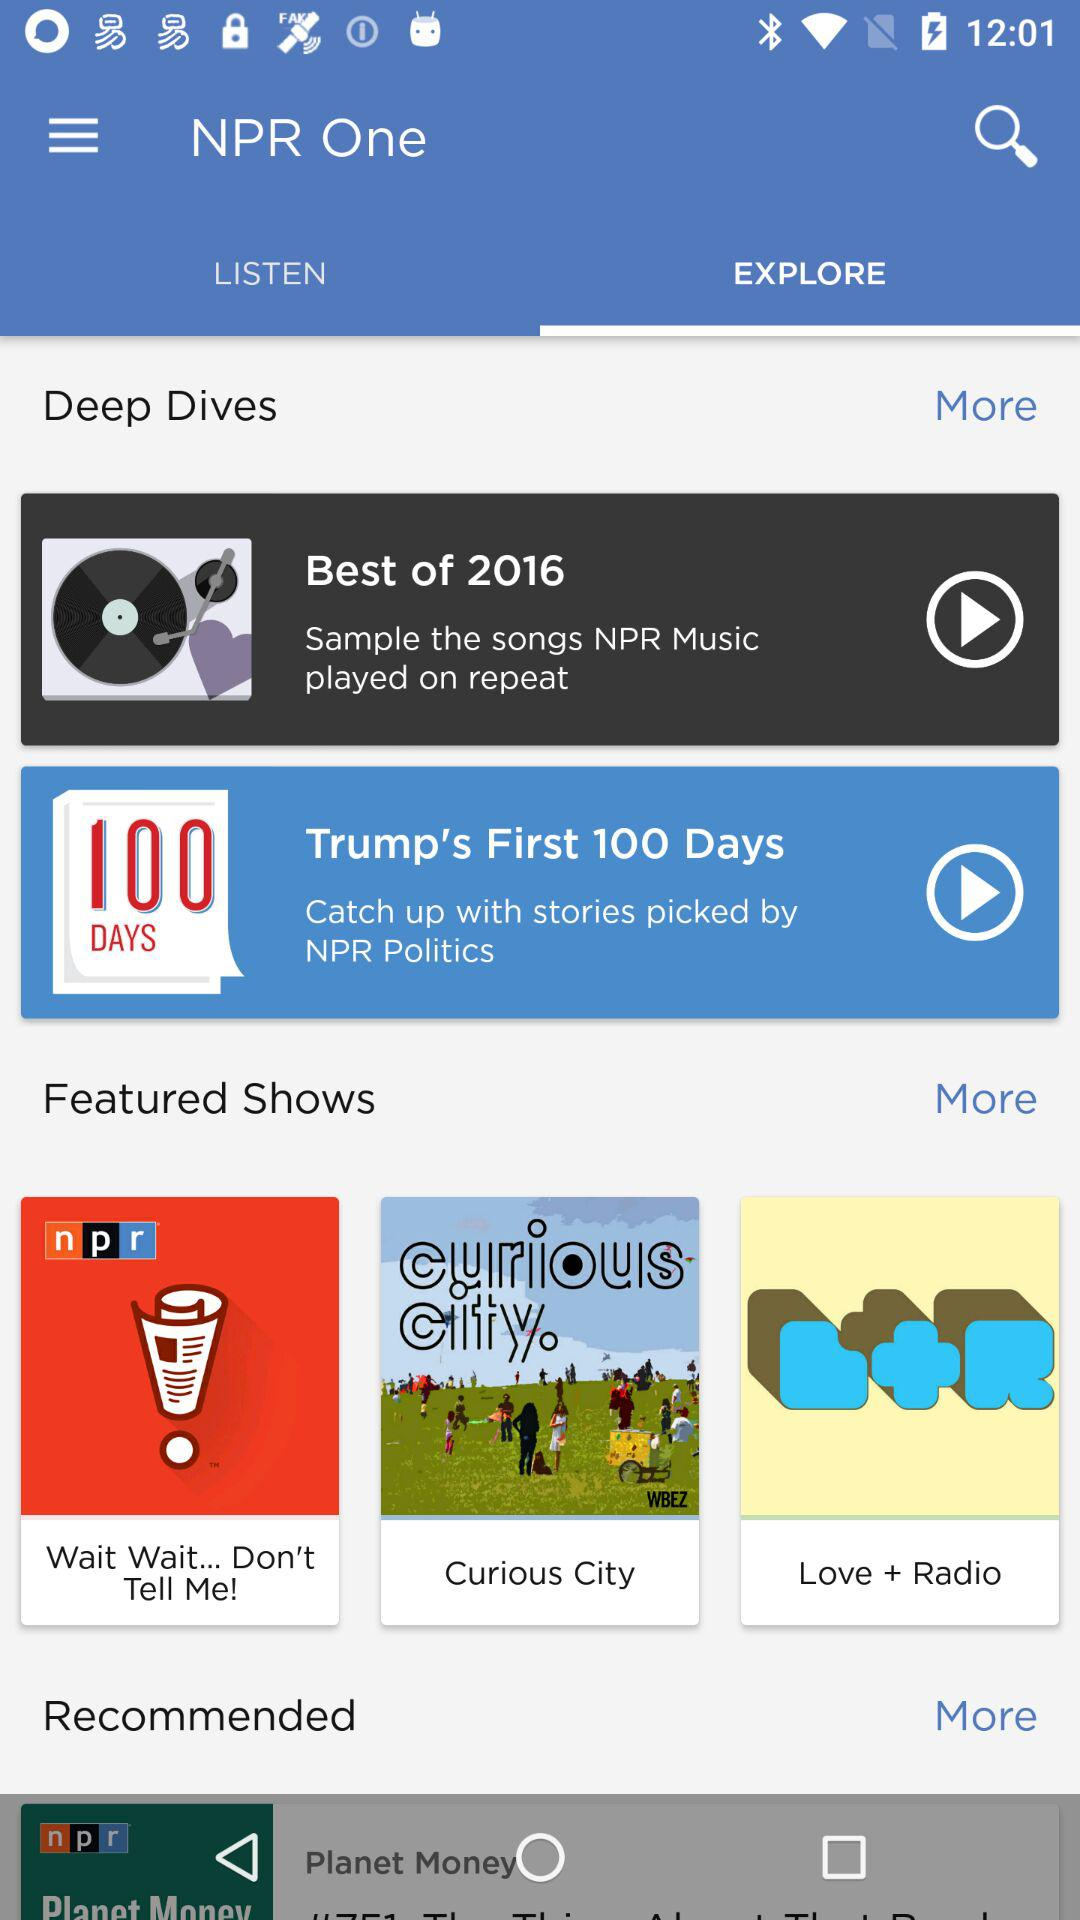Which tab is open? The open tab is "EXPLORE". 